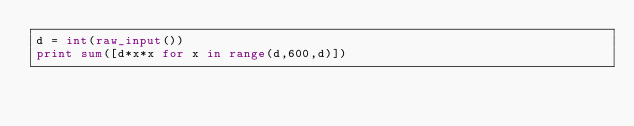<code> <loc_0><loc_0><loc_500><loc_500><_Python_>d = int(raw_input())
print sum([d*x*x for x in range(d,600,d)])</code> 